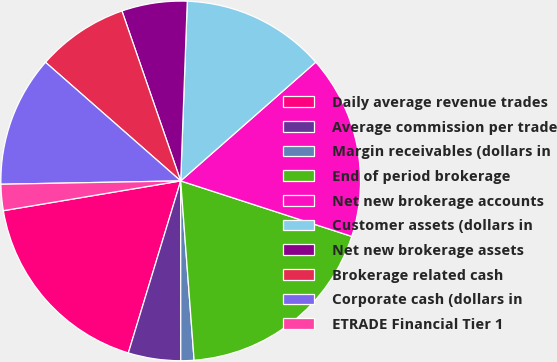<chart> <loc_0><loc_0><loc_500><loc_500><pie_chart><fcel>Daily average revenue trades<fcel>Average commission per trade<fcel>Margin receivables (dollars in<fcel>End of period brokerage<fcel>Net new brokerage accounts<fcel>Customer assets (dollars in<fcel>Net new brokerage assets<fcel>Brokerage related cash<fcel>Corporate cash (dollars in<fcel>ETRADE Financial Tier 1<nl><fcel>17.65%<fcel>4.71%<fcel>1.18%<fcel>18.82%<fcel>16.47%<fcel>12.94%<fcel>5.88%<fcel>8.24%<fcel>11.76%<fcel>2.35%<nl></chart> 